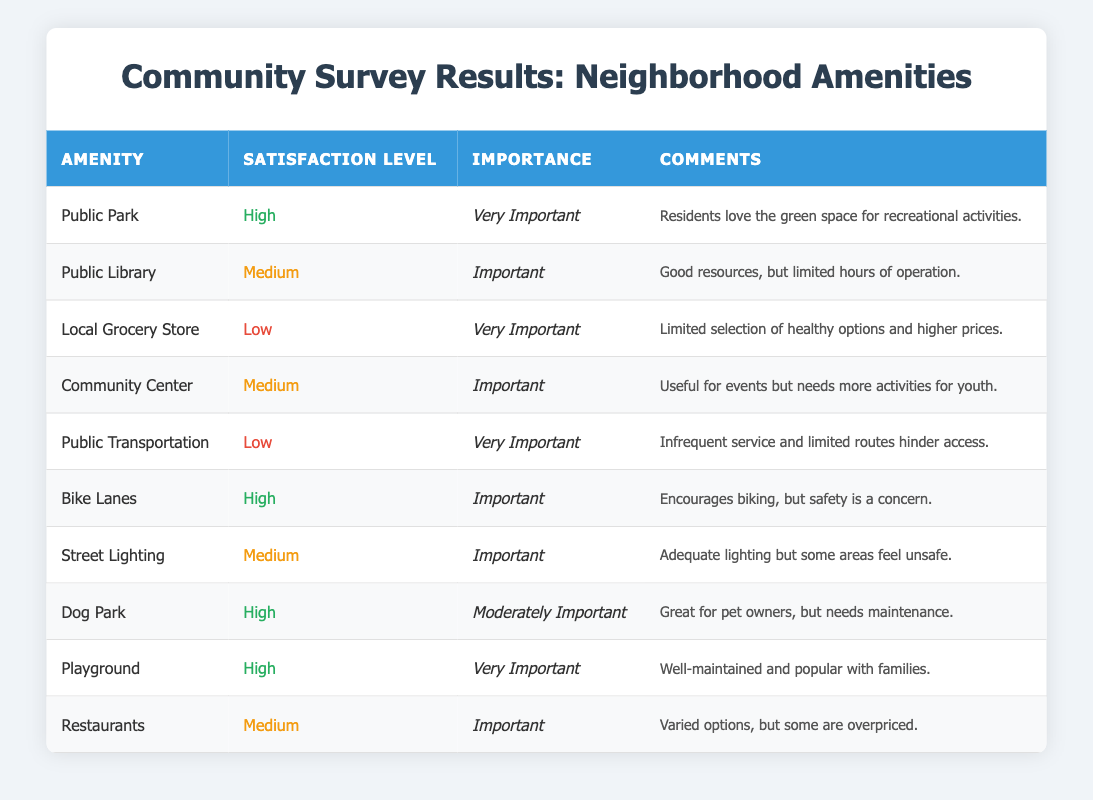What is the satisfaction level for the Public Park? The table shows that the satisfaction level for the Public Park is categorized as "High."
Answer: High Which amenity has the lowest satisfaction level? Reviewing the satisfaction levels across the amenities, the Local Grocery Store and Public Transportation both have "Low" satisfaction, but Local Grocery Store is listed first in the table.
Answer: Local Grocery Store How many amenities are classified as "Very Important"? There are a total of 5 amenities labeled as "Very Important" in the importance column: Public Park, Local Grocery Store, Public Transportation, Playground, and others.
Answer: 5 Is the satisfaction level for the Dog Park high or low? According to the table, the satisfaction level for the Dog Park is labeled as "High."
Answer: High What percentage of amenities have a satisfaction level categorized as "High"? There are 4 amenities with "High" satisfaction out of a total of 10 amenities. The percentage is (4/10) * 100 = 40%.
Answer: 40% Which amenities are considered "Important" but also have a satisfaction level of "Medium"? The amenities that are both "Important" and have "Medium" satisfaction are the Public Library, Community Center, Street Lighting, and Restaurants.
Answer: Public Library, Community Center, Street Lighting, Restaurants Are there any amenities that have "Low" satisfaction but are rated as "Very Important"? Yes, both the Local Grocery Store and Public Transportation have "Low" satisfaction levels and are categorized as "Very Important."
Answer: Yes What is the combined satisfaction level of the amenities that have "High" satisfaction? The amenities with "High" satisfaction are the Public Park, Bike Lanes, Dog Park, and Playground, which total 4. Therefore, the combined satisfaction level remains high.
Answer: 4 High Identify the amenity with the highest importance rating and what is its satisfaction level. The Playground is rated as "Very Important" and its satisfaction level is "High."
Answer: Playground, High How many amenities are "Moderately Important" and what is the satisfaction level of the Dog Park? There is 1 amenity, the Dog Park, rated as "Moderately Important," and its satisfaction level is "High."
Answer: 1, High What can be inferred about the overall satisfaction and importance level of the Public Transportation based on the survey results? Public Transportation is marked as "Very Important" but has a "Low" satisfaction level, indicating that residents consider it essential but are not satisfied with its current state.
Answer: Important, Low Satisfaction 